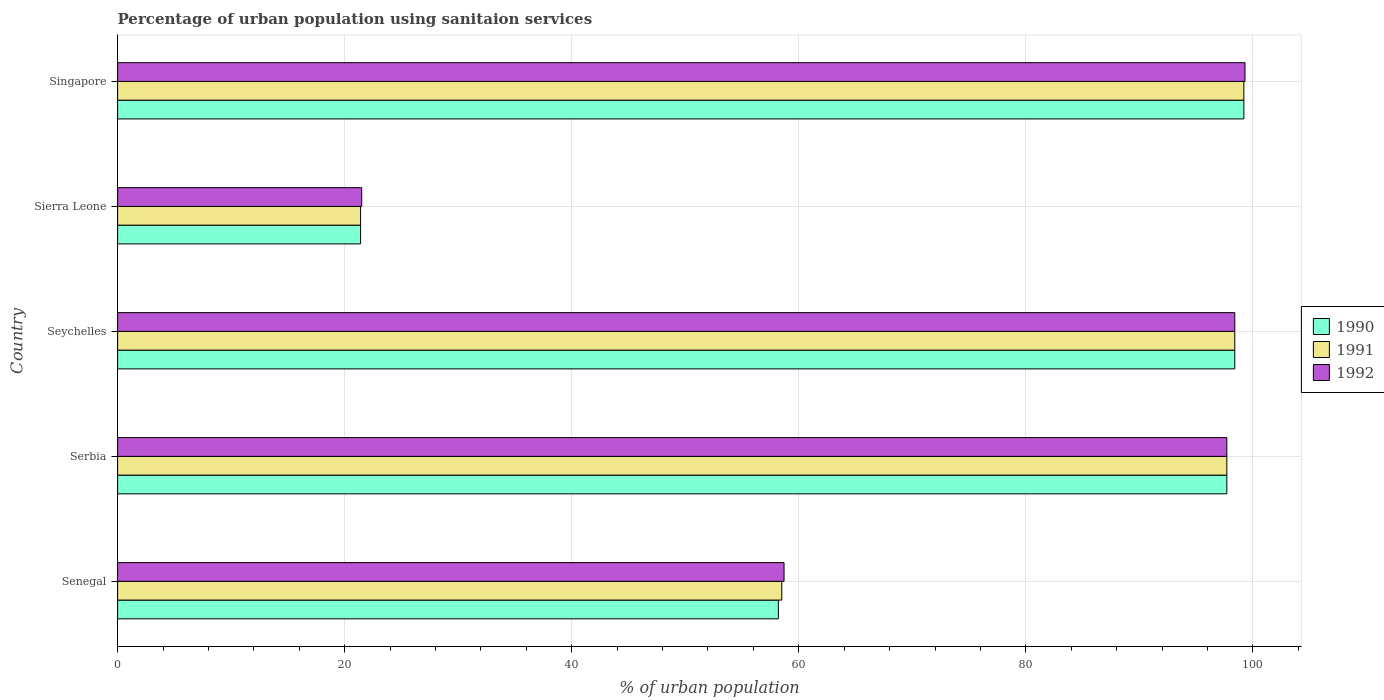Are the number of bars per tick equal to the number of legend labels?
Give a very brief answer. Yes. Are the number of bars on each tick of the Y-axis equal?
Ensure brevity in your answer.  Yes. How many bars are there on the 2nd tick from the top?
Your response must be concise. 3. What is the label of the 3rd group of bars from the top?
Provide a short and direct response. Seychelles. What is the percentage of urban population using sanitaion services in 1991 in Singapore?
Your answer should be compact. 99.2. Across all countries, what is the maximum percentage of urban population using sanitaion services in 1990?
Your response must be concise. 99.2. In which country was the percentage of urban population using sanitaion services in 1990 maximum?
Offer a terse response. Singapore. In which country was the percentage of urban population using sanitaion services in 1992 minimum?
Give a very brief answer. Sierra Leone. What is the total percentage of urban population using sanitaion services in 1990 in the graph?
Offer a very short reply. 374.9. What is the difference between the percentage of urban population using sanitaion services in 1991 in Senegal and that in Sierra Leone?
Your response must be concise. 37.1. What is the difference between the percentage of urban population using sanitaion services in 1990 in Sierra Leone and the percentage of urban population using sanitaion services in 1991 in Singapore?
Keep it short and to the point. -77.8. What is the average percentage of urban population using sanitaion services in 1991 per country?
Your response must be concise. 75.04. What is the difference between the percentage of urban population using sanitaion services in 1990 and percentage of urban population using sanitaion services in 1991 in Senegal?
Give a very brief answer. -0.3. In how many countries, is the percentage of urban population using sanitaion services in 1992 greater than 60 %?
Keep it short and to the point. 3. What is the ratio of the percentage of urban population using sanitaion services in 1992 in Senegal to that in Seychelles?
Ensure brevity in your answer.  0.6. Is the difference between the percentage of urban population using sanitaion services in 1990 in Senegal and Seychelles greater than the difference between the percentage of urban population using sanitaion services in 1991 in Senegal and Seychelles?
Your response must be concise. No. What is the difference between the highest and the second highest percentage of urban population using sanitaion services in 1992?
Your answer should be compact. 0.9. What is the difference between the highest and the lowest percentage of urban population using sanitaion services in 1990?
Give a very brief answer. 77.8. Is it the case that in every country, the sum of the percentage of urban population using sanitaion services in 1992 and percentage of urban population using sanitaion services in 1990 is greater than the percentage of urban population using sanitaion services in 1991?
Ensure brevity in your answer.  Yes. Are all the bars in the graph horizontal?
Your answer should be very brief. Yes. What is the difference between two consecutive major ticks on the X-axis?
Your response must be concise. 20. Does the graph contain any zero values?
Provide a succinct answer. No. Where does the legend appear in the graph?
Provide a short and direct response. Center right. How many legend labels are there?
Your response must be concise. 3. How are the legend labels stacked?
Ensure brevity in your answer.  Vertical. What is the title of the graph?
Ensure brevity in your answer.  Percentage of urban population using sanitaion services. Does "2012" appear as one of the legend labels in the graph?
Provide a short and direct response. No. What is the label or title of the X-axis?
Your answer should be compact. % of urban population. What is the % of urban population in 1990 in Senegal?
Keep it short and to the point. 58.2. What is the % of urban population of 1991 in Senegal?
Ensure brevity in your answer.  58.5. What is the % of urban population of 1992 in Senegal?
Your response must be concise. 58.7. What is the % of urban population of 1990 in Serbia?
Give a very brief answer. 97.7. What is the % of urban population of 1991 in Serbia?
Your response must be concise. 97.7. What is the % of urban population in 1992 in Serbia?
Your answer should be compact. 97.7. What is the % of urban population in 1990 in Seychelles?
Keep it short and to the point. 98.4. What is the % of urban population of 1991 in Seychelles?
Give a very brief answer. 98.4. What is the % of urban population in 1992 in Seychelles?
Your answer should be compact. 98.4. What is the % of urban population of 1990 in Sierra Leone?
Your answer should be compact. 21.4. What is the % of urban population in 1991 in Sierra Leone?
Keep it short and to the point. 21.4. What is the % of urban population in 1992 in Sierra Leone?
Make the answer very short. 21.5. What is the % of urban population of 1990 in Singapore?
Provide a succinct answer. 99.2. What is the % of urban population in 1991 in Singapore?
Provide a succinct answer. 99.2. What is the % of urban population of 1992 in Singapore?
Your response must be concise. 99.3. Across all countries, what is the maximum % of urban population of 1990?
Give a very brief answer. 99.2. Across all countries, what is the maximum % of urban population of 1991?
Offer a very short reply. 99.2. Across all countries, what is the maximum % of urban population in 1992?
Provide a succinct answer. 99.3. Across all countries, what is the minimum % of urban population in 1990?
Keep it short and to the point. 21.4. Across all countries, what is the minimum % of urban population of 1991?
Your answer should be compact. 21.4. Across all countries, what is the minimum % of urban population in 1992?
Make the answer very short. 21.5. What is the total % of urban population of 1990 in the graph?
Your response must be concise. 374.9. What is the total % of urban population of 1991 in the graph?
Make the answer very short. 375.2. What is the total % of urban population in 1992 in the graph?
Your answer should be very brief. 375.6. What is the difference between the % of urban population of 1990 in Senegal and that in Serbia?
Your answer should be compact. -39.5. What is the difference between the % of urban population in 1991 in Senegal and that in Serbia?
Make the answer very short. -39.2. What is the difference between the % of urban population of 1992 in Senegal and that in Serbia?
Your answer should be very brief. -39. What is the difference between the % of urban population of 1990 in Senegal and that in Seychelles?
Your response must be concise. -40.2. What is the difference between the % of urban population of 1991 in Senegal and that in Seychelles?
Provide a short and direct response. -39.9. What is the difference between the % of urban population in 1992 in Senegal and that in Seychelles?
Offer a terse response. -39.7. What is the difference between the % of urban population of 1990 in Senegal and that in Sierra Leone?
Your answer should be compact. 36.8. What is the difference between the % of urban population in 1991 in Senegal and that in Sierra Leone?
Make the answer very short. 37.1. What is the difference between the % of urban population in 1992 in Senegal and that in Sierra Leone?
Provide a succinct answer. 37.2. What is the difference between the % of urban population of 1990 in Senegal and that in Singapore?
Give a very brief answer. -41. What is the difference between the % of urban population of 1991 in Senegal and that in Singapore?
Ensure brevity in your answer.  -40.7. What is the difference between the % of urban population of 1992 in Senegal and that in Singapore?
Your answer should be compact. -40.6. What is the difference between the % of urban population of 1990 in Serbia and that in Seychelles?
Provide a short and direct response. -0.7. What is the difference between the % of urban population in 1992 in Serbia and that in Seychelles?
Give a very brief answer. -0.7. What is the difference between the % of urban population of 1990 in Serbia and that in Sierra Leone?
Your response must be concise. 76.3. What is the difference between the % of urban population in 1991 in Serbia and that in Sierra Leone?
Your response must be concise. 76.3. What is the difference between the % of urban population of 1992 in Serbia and that in Sierra Leone?
Give a very brief answer. 76.2. What is the difference between the % of urban population in 1990 in Seychelles and that in Sierra Leone?
Give a very brief answer. 77. What is the difference between the % of urban population in 1991 in Seychelles and that in Sierra Leone?
Give a very brief answer. 77. What is the difference between the % of urban population of 1992 in Seychelles and that in Sierra Leone?
Provide a succinct answer. 76.9. What is the difference between the % of urban population of 1990 in Sierra Leone and that in Singapore?
Ensure brevity in your answer.  -77.8. What is the difference between the % of urban population of 1991 in Sierra Leone and that in Singapore?
Offer a terse response. -77.8. What is the difference between the % of urban population in 1992 in Sierra Leone and that in Singapore?
Offer a terse response. -77.8. What is the difference between the % of urban population in 1990 in Senegal and the % of urban population in 1991 in Serbia?
Keep it short and to the point. -39.5. What is the difference between the % of urban population in 1990 in Senegal and the % of urban population in 1992 in Serbia?
Offer a very short reply. -39.5. What is the difference between the % of urban population in 1991 in Senegal and the % of urban population in 1992 in Serbia?
Ensure brevity in your answer.  -39.2. What is the difference between the % of urban population in 1990 in Senegal and the % of urban population in 1991 in Seychelles?
Offer a very short reply. -40.2. What is the difference between the % of urban population in 1990 in Senegal and the % of urban population in 1992 in Seychelles?
Provide a short and direct response. -40.2. What is the difference between the % of urban population of 1991 in Senegal and the % of urban population of 1992 in Seychelles?
Your answer should be very brief. -39.9. What is the difference between the % of urban population in 1990 in Senegal and the % of urban population in 1991 in Sierra Leone?
Provide a short and direct response. 36.8. What is the difference between the % of urban population in 1990 in Senegal and the % of urban population in 1992 in Sierra Leone?
Your answer should be compact. 36.7. What is the difference between the % of urban population in 1990 in Senegal and the % of urban population in 1991 in Singapore?
Give a very brief answer. -41. What is the difference between the % of urban population in 1990 in Senegal and the % of urban population in 1992 in Singapore?
Provide a succinct answer. -41.1. What is the difference between the % of urban population of 1991 in Senegal and the % of urban population of 1992 in Singapore?
Provide a succinct answer. -40.8. What is the difference between the % of urban population of 1991 in Serbia and the % of urban population of 1992 in Seychelles?
Your response must be concise. -0.7. What is the difference between the % of urban population in 1990 in Serbia and the % of urban population in 1991 in Sierra Leone?
Provide a succinct answer. 76.3. What is the difference between the % of urban population of 1990 in Serbia and the % of urban population of 1992 in Sierra Leone?
Make the answer very short. 76.2. What is the difference between the % of urban population of 1991 in Serbia and the % of urban population of 1992 in Sierra Leone?
Your response must be concise. 76.2. What is the difference between the % of urban population of 1990 in Serbia and the % of urban population of 1992 in Singapore?
Make the answer very short. -1.6. What is the difference between the % of urban population in 1990 in Seychelles and the % of urban population in 1992 in Sierra Leone?
Offer a very short reply. 76.9. What is the difference between the % of urban population of 1991 in Seychelles and the % of urban population of 1992 in Sierra Leone?
Make the answer very short. 76.9. What is the difference between the % of urban population of 1990 in Seychelles and the % of urban population of 1992 in Singapore?
Provide a short and direct response. -0.9. What is the difference between the % of urban population of 1991 in Seychelles and the % of urban population of 1992 in Singapore?
Your response must be concise. -0.9. What is the difference between the % of urban population in 1990 in Sierra Leone and the % of urban population in 1991 in Singapore?
Ensure brevity in your answer.  -77.8. What is the difference between the % of urban population in 1990 in Sierra Leone and the % of urban population in 1992 in Singapore?
Offer a very short reply. -77.9. What is the difference between the % of urban population of 1991 in Sierra Leone and the % of urban population of 1992 in Singapore?
Your answer should be compact. -77.9. What is the average % of urban population in 1990 per country?
Your answer should be compact. 74.98. What is the average % of urban population of 1991 per country?
Offer a very short reply. 75.04. What is the average % of urban population in 1992 per country?
Give a very brief answer. 75.12. What is the difference between the % of urban population of 1990 and % of urban population of 1991 in Senegal?
Your answer should be very brief. -0.3. What is the difference between the % of urban population of 1990 and % of urban population of 1992 in Senegal?
Your response must be concise. -0.5. What is the difference between the % of urban population of 1991 and % of urban population of 1992 in Senegal?
Provide a short and direct response. -0.2. What is the difference between the % of urban population in 1990 and % of urban population in 1991 in Serbia?
Keep it short and to the point. 0. What is the difference between the % of urban population of 1990 and % of urban population of 1991 in Seychelles?
Make the answer very short. 0. What is the difference between the % of urban population in 1990 and % of urban population in 1992 in Seychelles?
Keep it short and to the point. 0. What is the difference between the % of urban population in 1991 and % of urban population in 1992 in Seychelles?
Provide a succinct answer. 0. What is the difference between the % of urban population of 1990 and % of urban population of 1991 in Sierra Leone?
Keep it short and to the point. 0. What is the difference between the % of urban population in 1991 and % of urban population in 1992 in Sierra Leone?
Provide a short and direct response. -0.1. What is the difference between the % of urban population of 1990 and % of urban population of 1991 in Singapore?
Keep it short and to the point. 0. What is the ratio of the % of urban population of 1990 in Senegal to that in Serbia?
Offer a terse response. 0.6. What is the ratio of the % of urban population of 1991 in Senegal to that in Serbia?
Make the answer very short. 0.6. What is the ratio of the % of urban population of 1992 in Senegal to that in Serbia?
Provide a succinct answer. 0.6. What is the ratio of the % of urban population of 1990 in Senegal to that in Seychelles?
Your response must be concise. 0.59. What is the ratio of the % of urban population of 1991 in Senegal to that in Seychelles?
Your answer should be compact. 0.59. What is the ratio of the % of urban population in 1992 in Senegal to that in Seychelles?
Your answer should be compact. 0.6. What is the ratio of the % of urban population in 1990 in Senegal to that in Sierra Leone?
Offer a very short reply. 2.72. What is the ratio of the % of urban population in 1991 in Senegal to that in Sierra Leone?
Offer a terse response. 2.73. What is the ratio of the % of urban population in 1992 in Senegal to that in Sierra Leone?
Provide a succinct answer. 2.73. What is the ratio of the % of urban population in 1990 in Senegal to that in Singapore?
Provide a succinct answer. 0.59. What is the ratio of the % of urban population in 1991 in Senegal to that in Singapore?
Give a very brief answer. 0.59. What is the ratio of the % of urban population of 1992 in Senegal to that in Singapore?
Provide a succinct answer. 0.59. What is the ratio of the % of urban population in 1990 in Serbia to that in Seychelles?
Offer a very short reply. 0.99. What is the ratio of the % of urban population of 1992 in Serbia to that in Seychelles?
Provide a short and direct response. 0.99. What is the ratio of the % of urban population of 1990 in Serbia to that in Sierra Leone?
Ensure brevity in your answer.  4.57. What is the ratio of the % of urban population in 1991 in Serbia to that in Sierra Leone?
Offer a terse response. 4.57. What is the ratio of the % of urban population of 1992 in Serbia to that in Sierra Leone?
Ensure brevity in your answer.  4.54. What is the ratio of the % of urban population in 1990 in Serbia to that in Singapore?
Provide a succinct answer. 0.98. What is the ratio of the % of urban population in 1991 in Serbia to that in Singapore?
Offer a terse response. 0.98. What is the ratio of the % of urban population in 1992 in Serbia to that in Singapore?
Ensure brevity in your answer.  0.98. What is the ratio of the % of urban population of 1990 in Seychelles to that in Sierra Leone?
Your response must be concise. 4.6. What is the ratio of the % of urban population of 1991 in Seychelles to that in Sierra Leone?
Provide a short and direct response. 4.6. What is the ratio of the % of urban population in 1992 in Seychelles to that in Sierra Leone?
Offer a terse response. 4.58. What is the ratio of the % of urban population in 1991 in Seychelles to that in Singapore?
Give a very brief answer. 0.99. What is the ratio of the % of urban population in 1992 in Seychelles to that in Singapore?
Keep it short and to the point. 0.99. What is the ratio of the % of urban population of 1990 in Sierra Leone to that in Singapore?
Provide a succinct answer. 0.22. What is the ratio of the % of urban population of 1991 in Sierra Leone to that in Singapore?
Offer a very short reply. 0.22. What is the ratio of the % of urban population of 1992 in Sierra Leone to that in Singapore?
Your answer should be very brief. 0.22. What is the difference between the highest and the second highest % of urban population of 1990?
Provide a succinct answer. 0.8. What is the difference between the highest and the lowest % of urban population in 1990?
Give a very brief answer. 77.8. What is the difference between the highest and the lowest % of urban population in 1991?
Offer a terse response. 77.8. What is the difference between the highest and the lowest % of urban population in 1992?
Keep it short and to the point. 77.8. 